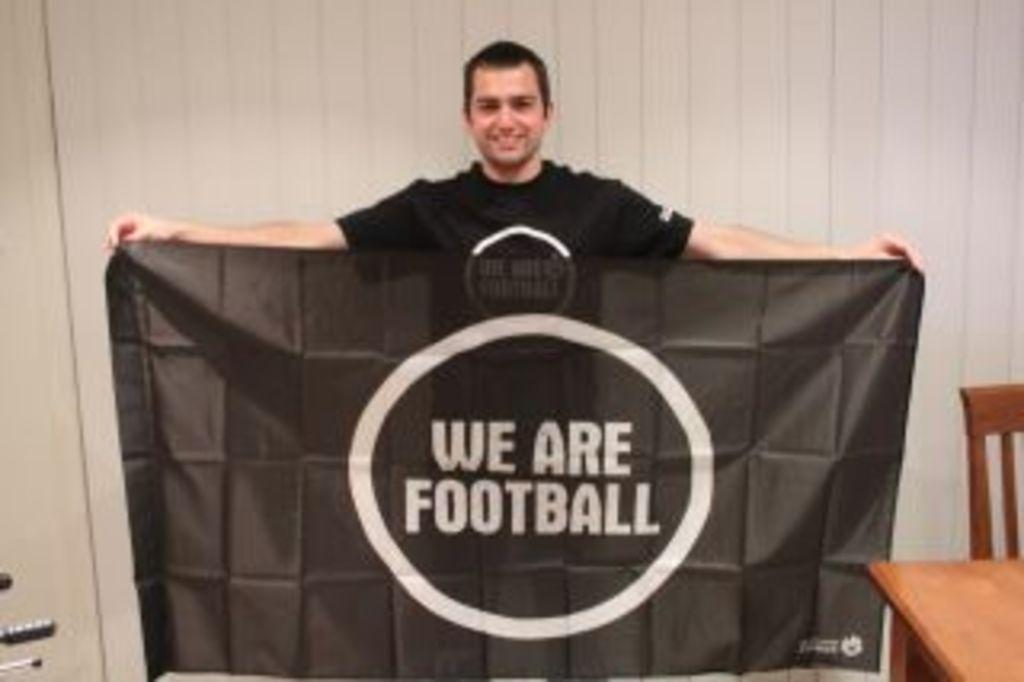What is the main subject of the image? There is a man standing in the center of the image. What is the man holding in the image? The man is holding a cloth. What is written on the cloth? The cloth has the words "We Are Football" written on it. What is the man's facial expression in the image? The man is smiling. What can be seen in the background of the image? There is a wall visible in the image. Are there any other objects or furniture in the image? Yes, there is a chair in the image. Can you see any fangs on the man in the image? There are no fangs visible on the man in the image. Is there a playground visible in the image? There is no playground present in the image. 